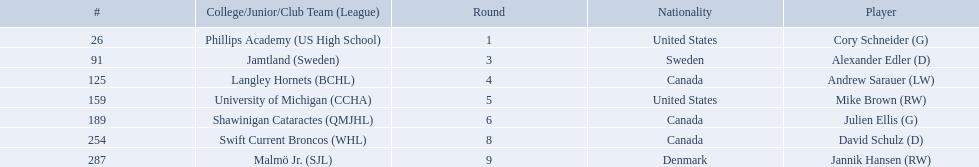Who are the players? Cory Schneider (G), Alexander Edler (D), Andrew Sarauer (LW), Mike Brown (RW), Julien Ellis (G), David Schulz (D), Jannik Hansen (RW). Parse the table in full. {'header': ['#', 'College/Junior/Club Team (League)', 'Round', 'Nationality', 'Player'], 'rows': [['26', 'Phillips Academy (US High School)', '1', 'United States', 'Cory Schneider (G)'], ['91', 'Jamtland (Sweden)', '3', 'Sweden', 'Alexander Edler (D)'], ['125', 'Langley Hornets (BCHL)', '4', 'Canada', 'Andrew Sarauer (LW)'], ['159', 'University of Michigan (CCHA)', '5', 'United States', 'Mike Brown (RW)'], ['189', 'Shawinigan Cataractes (QMJHL)', '6', 'Canada', 'Julien Ellis (G)'], ['254', 'Swift Current Broncos (WHL)', '8', 'Canada', 'David Schulz (D)'], ['287', 'Malmö Jr. (SJL)', '9', 'Denmark', 'Jannik Hansen (RW)']]} Of those, who is from denmark? Jannik Hansen (RW). 